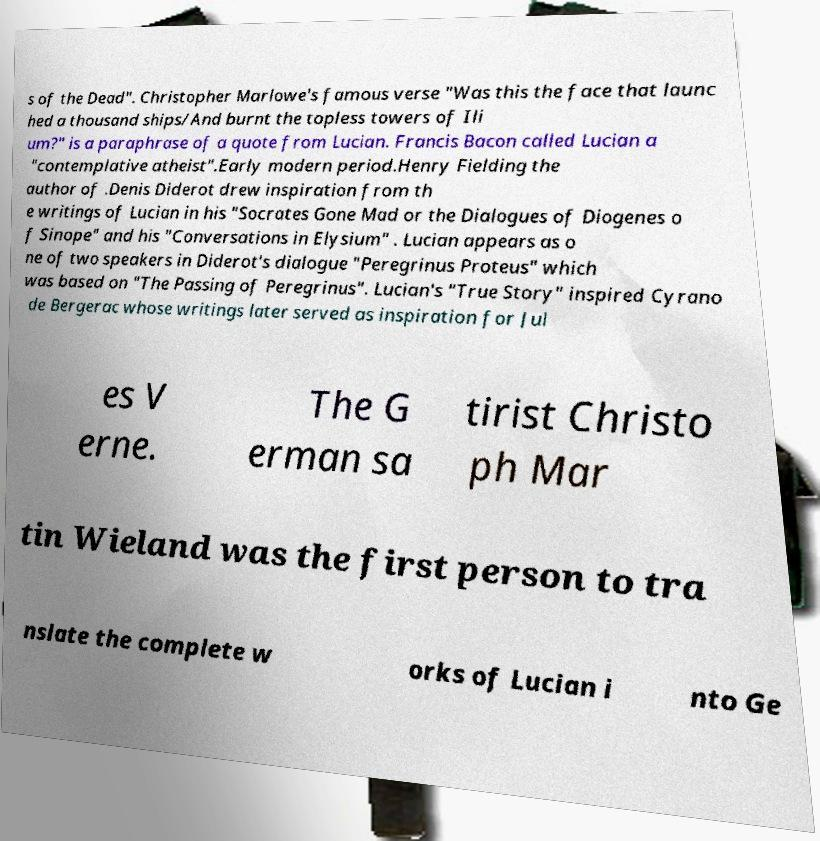There's text embedded in this image that I need extracted. Can you transcribe it verbatim? s of the Dead". Christopher Marlowe's famous verse "Was this the face that launc hed a thousand ships/And burnt the topless towers of Ili um?" is a paraphrase of a quote from Lucian. Francis Bacon called Lucian a "contemplative atheist".Early modern period.Henry Fielding the author of .Denis Diderot drew inspiration from th e writings of Lucian in his "Socrates Gone Mad or the Dialogues of Diogenes o f Sinope" and his "Conversations in Elysium" . Lucian appears as o ne of two speakers in Diderot's dialogue "Peregrinus Proteus" which was based on "The Passing of Peregrinus". Lucian's "True Story" inspired Cyrano de Bergerac whose writings later served as inspiration for Jul es V erne. The G erman sa tirist Christo ph Mar tin Wieland was the first person to tra nslate the complete w orks of Lucian i nto Ge 